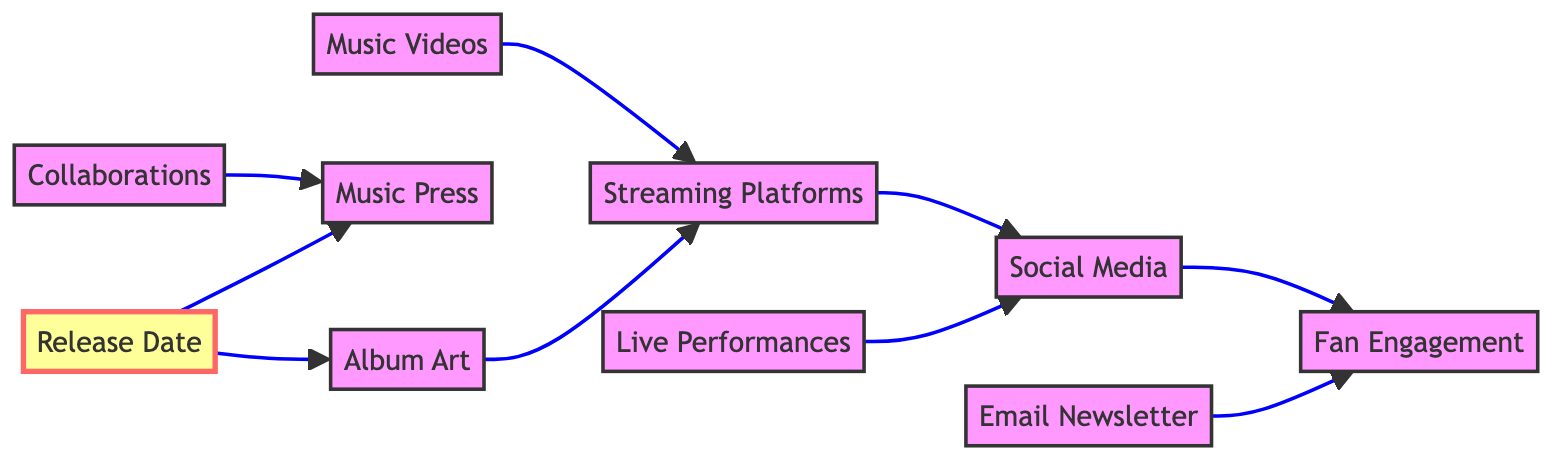What node leads to Fan Engagement? The diagram shows two edges leading to the node "Fan Engagement", specifically from "Social Media" and "Email Newsletter". By tracing these edges, it becomes clear that both nodes contribute to fan engagement.
Answer: Social Media, Email Newsletter How many nodes are in the diagram? By counting the unique nodes listed in the diagram, we find 10 distinct nodes: Social Media, Email Newsletter, Streaming Platforms, Music Videos, Live Performances, Collaborations, Music Press, Fan Engagement, Release Date, Album Art.
Answer: 10 What is the first milestone in the diagram? The only node labeled as a milestone in the diagram is "Release Date", which is visually denoted with a different size and font weight, indicating its significance.
Answer: Release Date Which node is connected to Album Art? The edge shows that "Album Art" is connected to "Streaming Platforms". This relationship means that after the album art is finalized, it will lead to promotion on streaming platforms.
Answer: Streaming Platforms Which nodes directly connect to Social Media? Tracing the edges from "Social Media", we see it connects directly to "Fan Engagement" and also receives connections from "Streaming Platforms" and "Live Performances". This indicates a network of interactions involving social media.
Answer: Fan Engagement, Streaming Platforms, Live Performances What role do Collaborations play in the diagram? Looking closely, "Collaborations" has a direct edge to "Music Press", indicating that any collaborations will be promoted through music press, helping in album marketing.
Answer: Music Press 